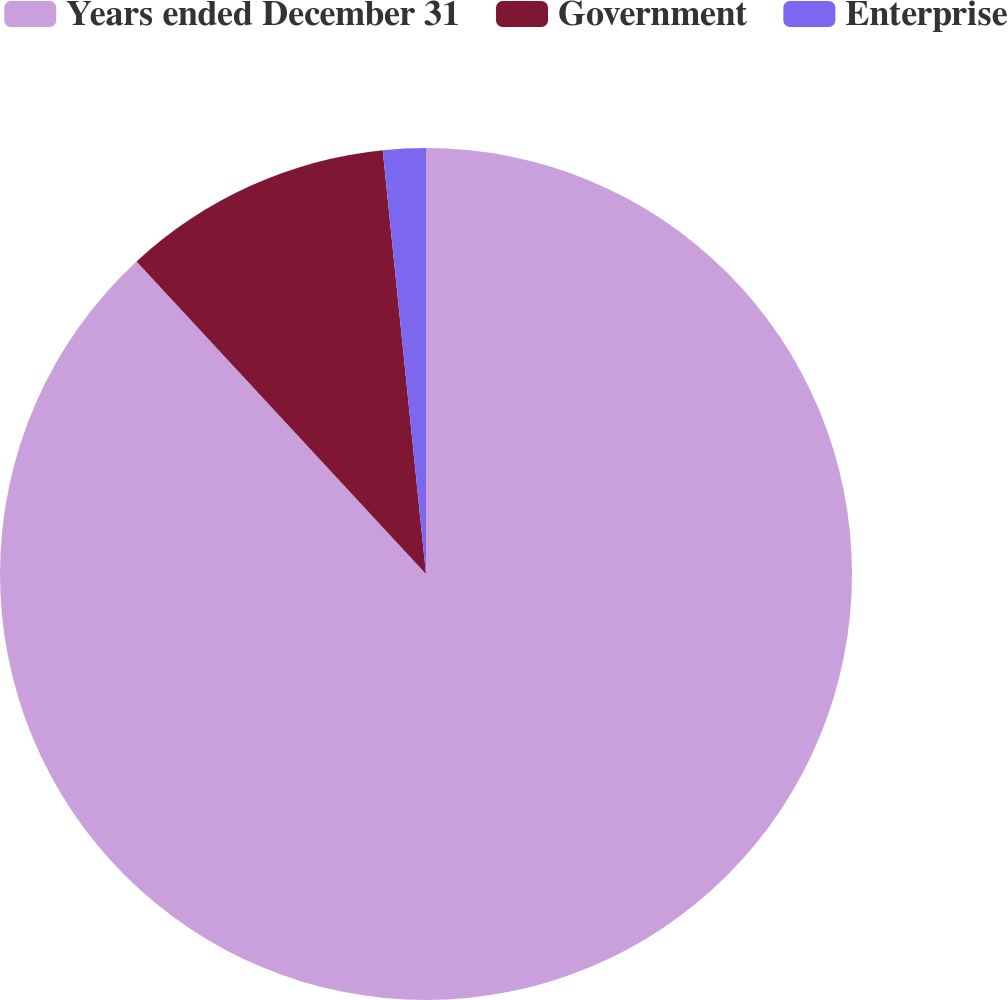Convert chart to OTSL. <chart><loc_0><loc_0><loc_500><loc_500><pie_chart><fcel>Years ended December 31<fcel>Government<fcel>Enterprise<nl><fcel>88.11%<fcel>10.27%<fcel>1.62%<nl></chart> 